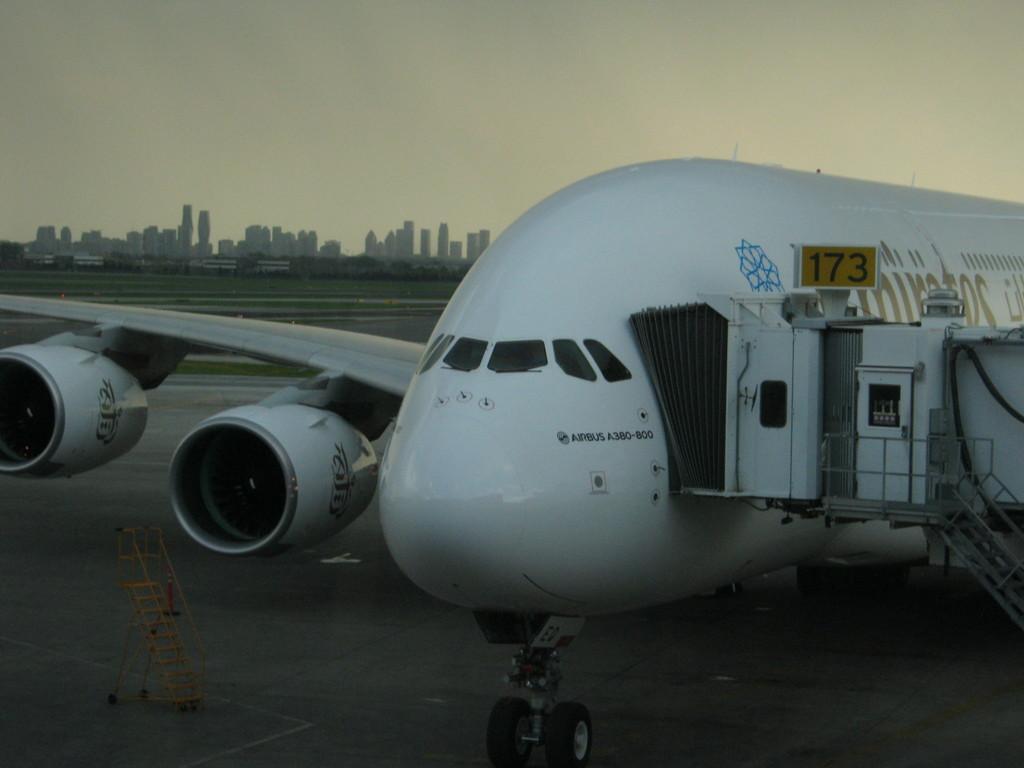In one or two sentences, can you explain what this image depicts? In this picture we can see an aircraft on a runway. There is a stand visible on the left side. We can see some greenery and the buildings in the background. We can see the sky on top of the picture. 